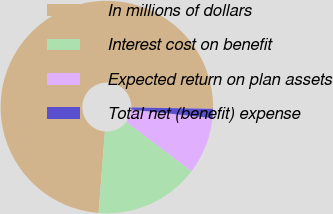<chart> <loc_0><loc_0><loc_500><loc_500><pie_chart><fcel>In millions of dollars<fcel>Interest cost on benefit<fcel>Expected return on plan assets<fcel>Total net (benefit) expense<nl><fcel>74.03%<fcel>15.92%<fcel>8.66%<fcel>1.4%<nl></chart> 